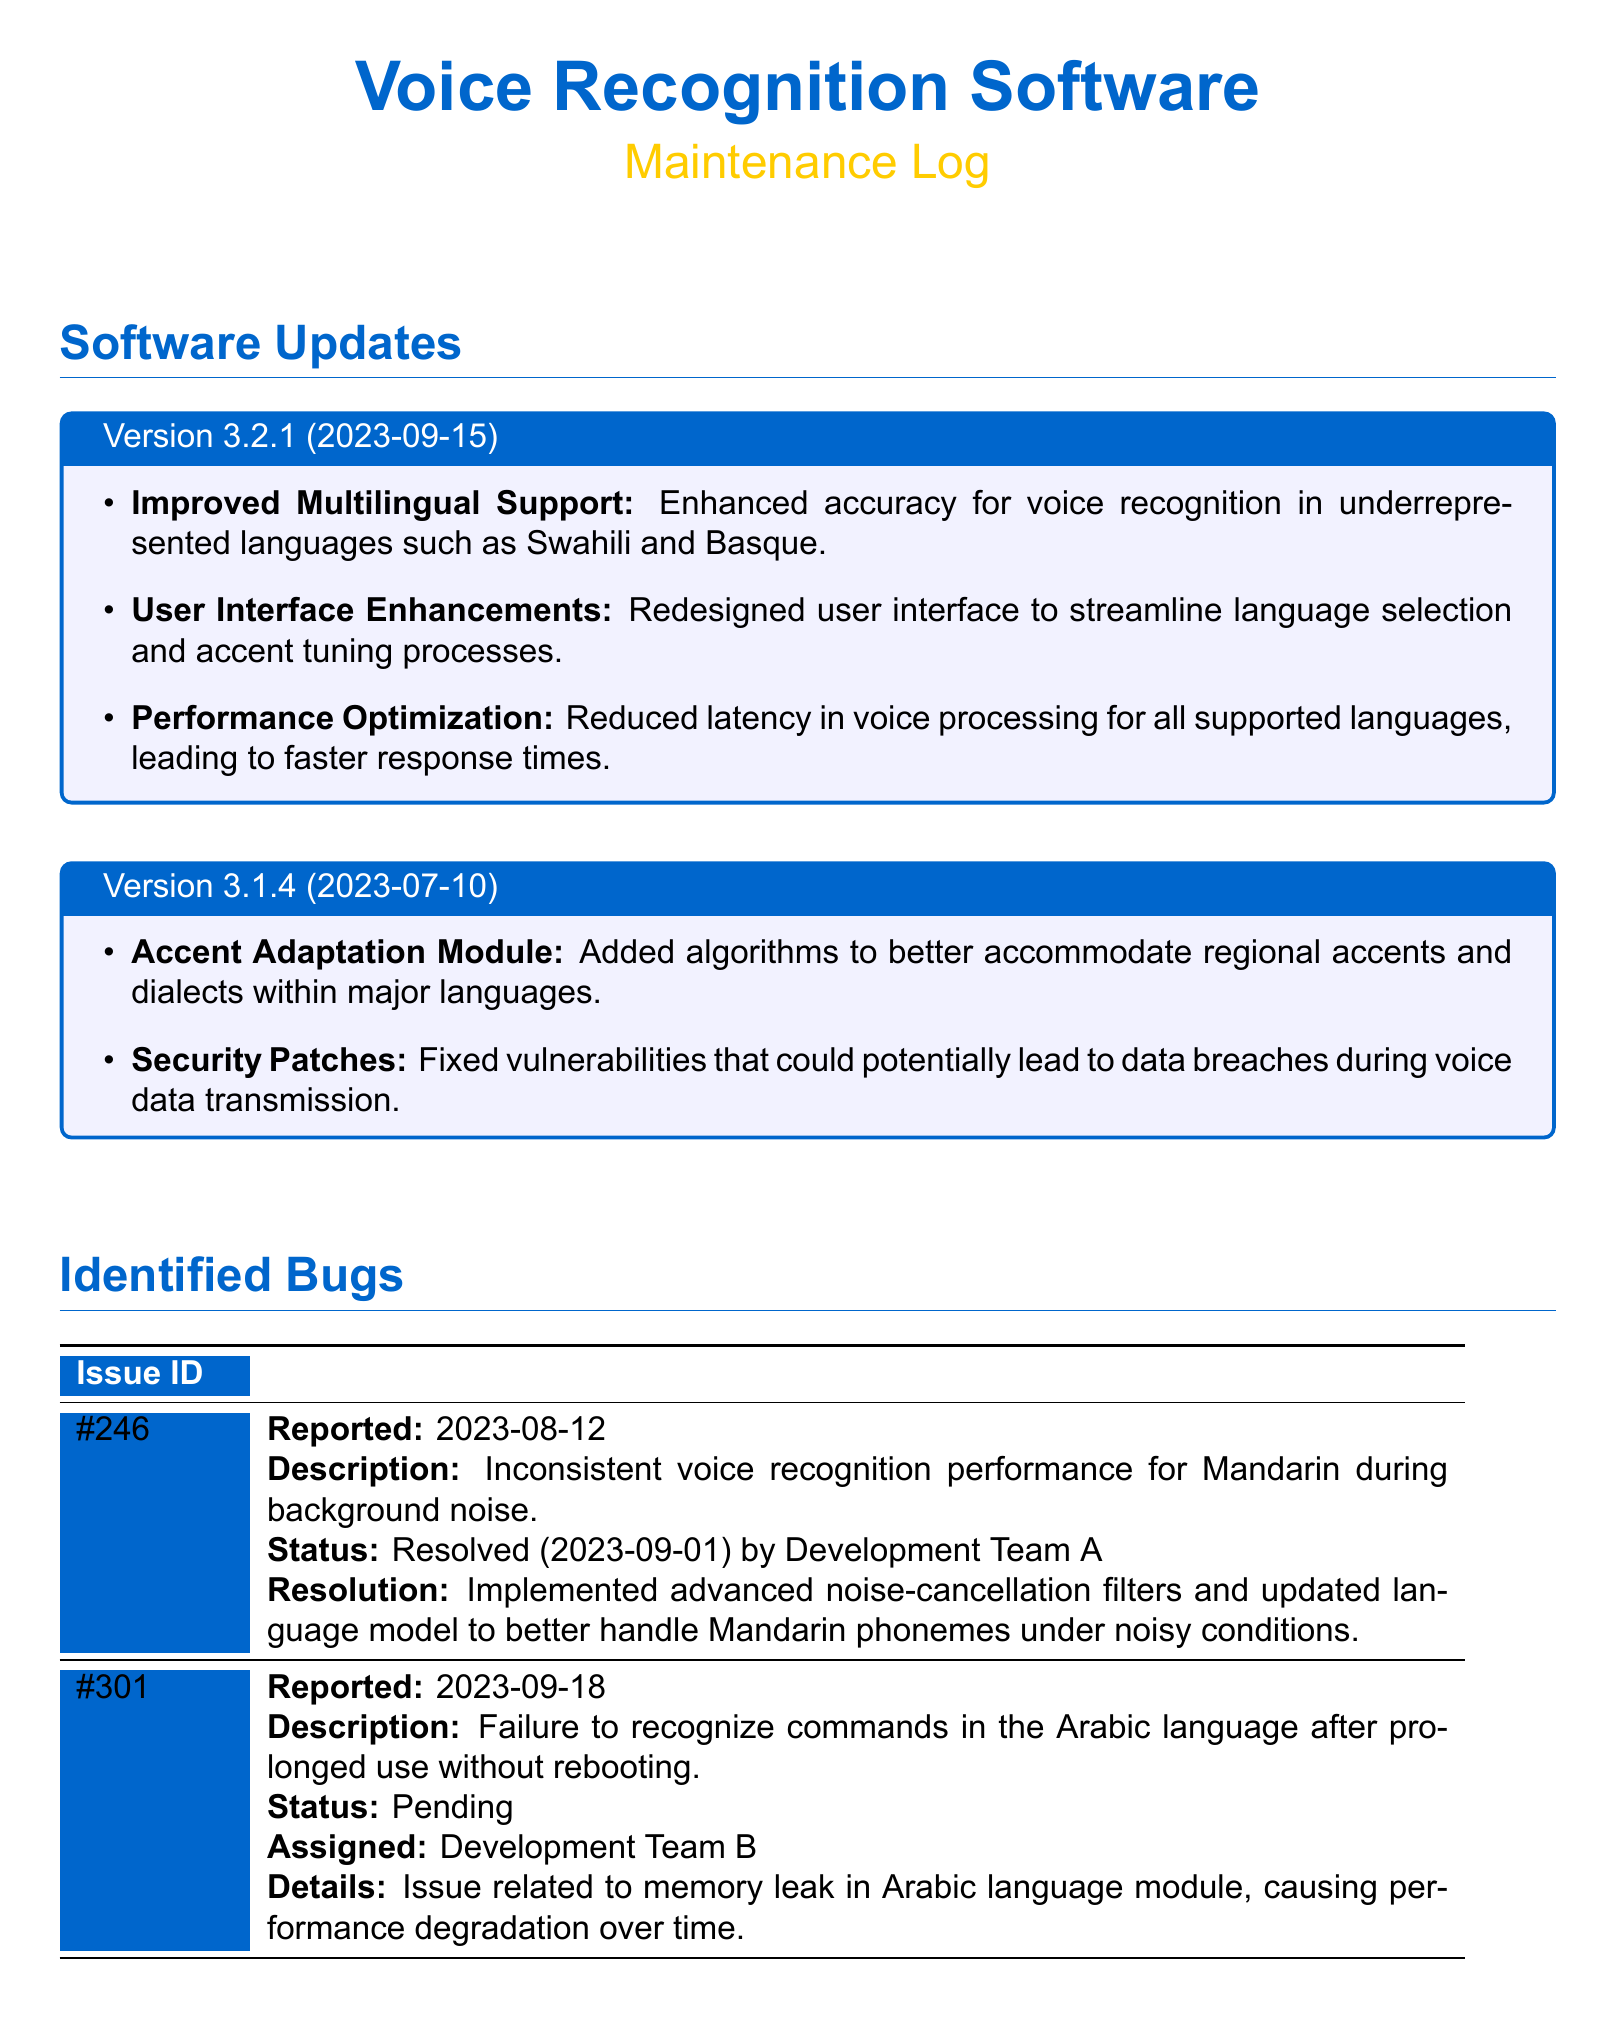what is the version number of the latest software update? The latest software update listed in the document is Version 3.2.1.
Answer: Version 3.2.1 when was Version 3.2.1 released? The release date of Version 3.2.1 is stated as 2023-09-15.
Answer: 2023-09-15 what is the issue ID for the bug related to Mandarin voice recognition? The issue ID for the bug related to Mandarin voice recognition is #246.
Answer: #246 what is the status of the bug reported on 2023-09-18? The status of the bug reported on 2023-09-18 is Pending.
Answer: Pending which development team resolved the Mandarin recognition performance issue? The development team that resolved the Mandarin recognition performance issue is Development Team A.
Answer: Development Team A how many software updates are listed in the document? The document lists two software updates: Version 3.2.1 and Version 3.1.4.
Answer: Two what type of enhancements were made in Version 3.2.1? Version 3.2.1 includes improved multilingual support, user interface enhancements, and performance optimization.
Answer: Improved multilingual support, user interface enhancements, performance optimization what was the resolution for the bug #246? The resolution for bug #246 was the implementation of advanced noise-cancellation filters and updates to the language model.
Answer: Implemented advanced noise-cancellation filters and updated language model which language module has a memory leak issue? The language module with a memory leak issue is the Arabic language module.
Answer: Arabic language module 